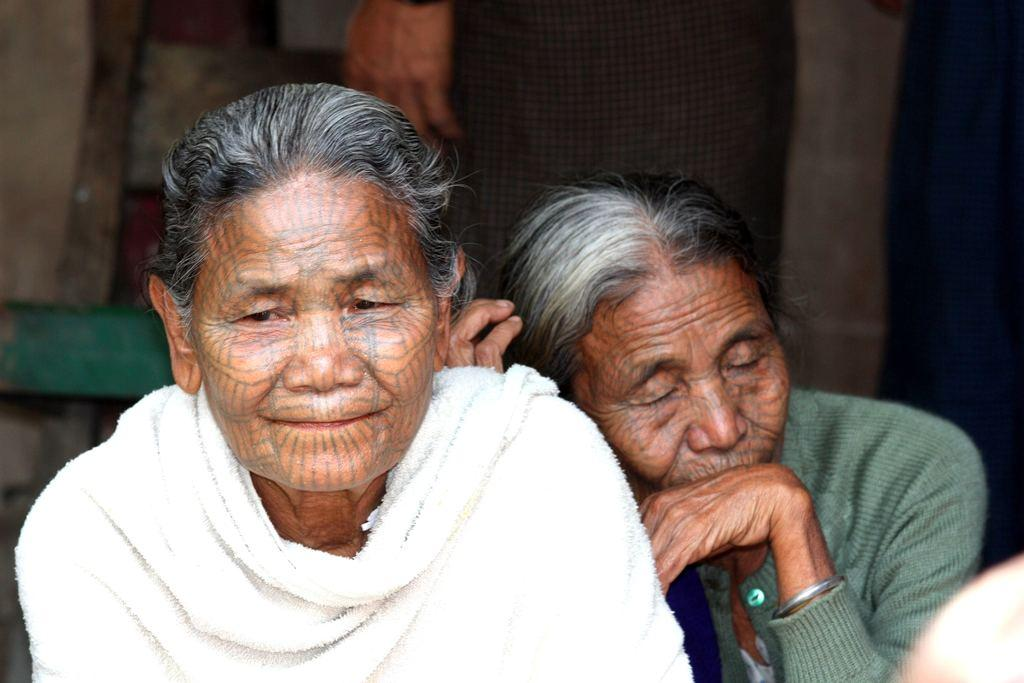What is the main subject of the image? The main subject of the image is a group of people. Can you describe the background of the image? The background of the image is blurry. What type of card is being held by the person in the image? There is no card visible in the image. Is there a flame or spark present in the image? No, there is no flame or spark present in the image. 